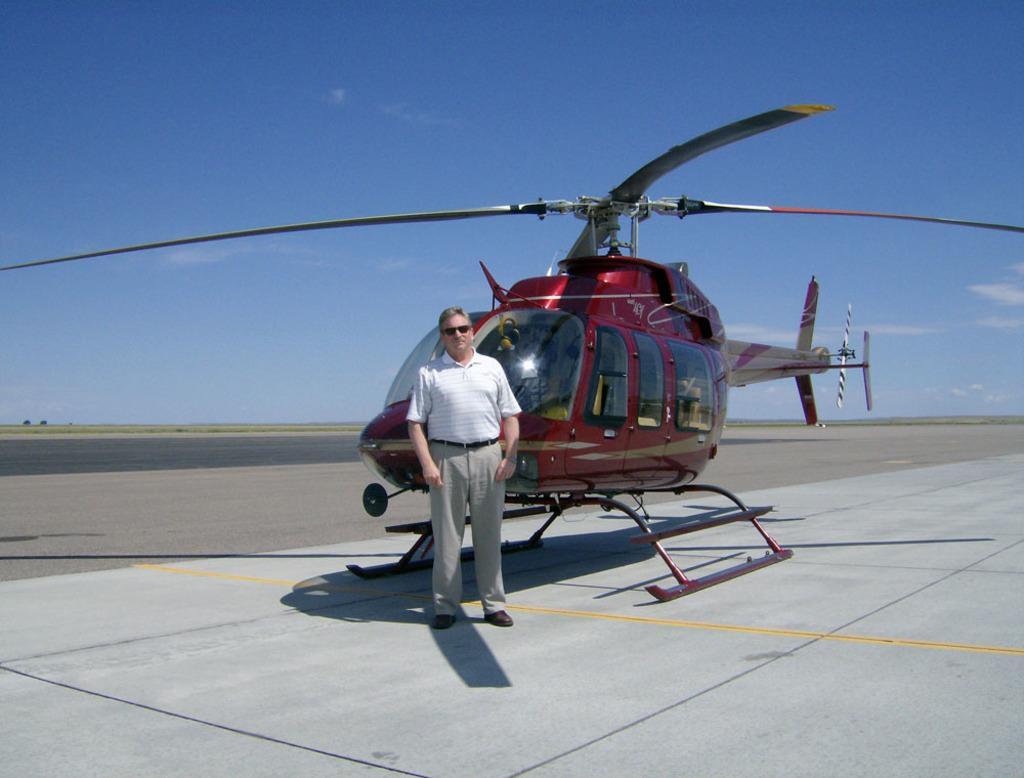Please provide a concise description of this image. In the center of the image there is a chopper. There is a person standing in front of it. In the background of the image there is sky. 